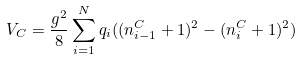Convert formula to latex. <formula><loc_0><loc_0><loc_500><loc_500>V _ { C } = \frac { g ^ { 2 } } { 8 } \sum _ { i = 1 } ^ { N } q _ { i } ( ( n _ { i - 1 } ^ { C } + 1 ) ^ { 2 } - ( n _ { i } ^ { C } + 1 ) ^ { 2 } )</formula> 